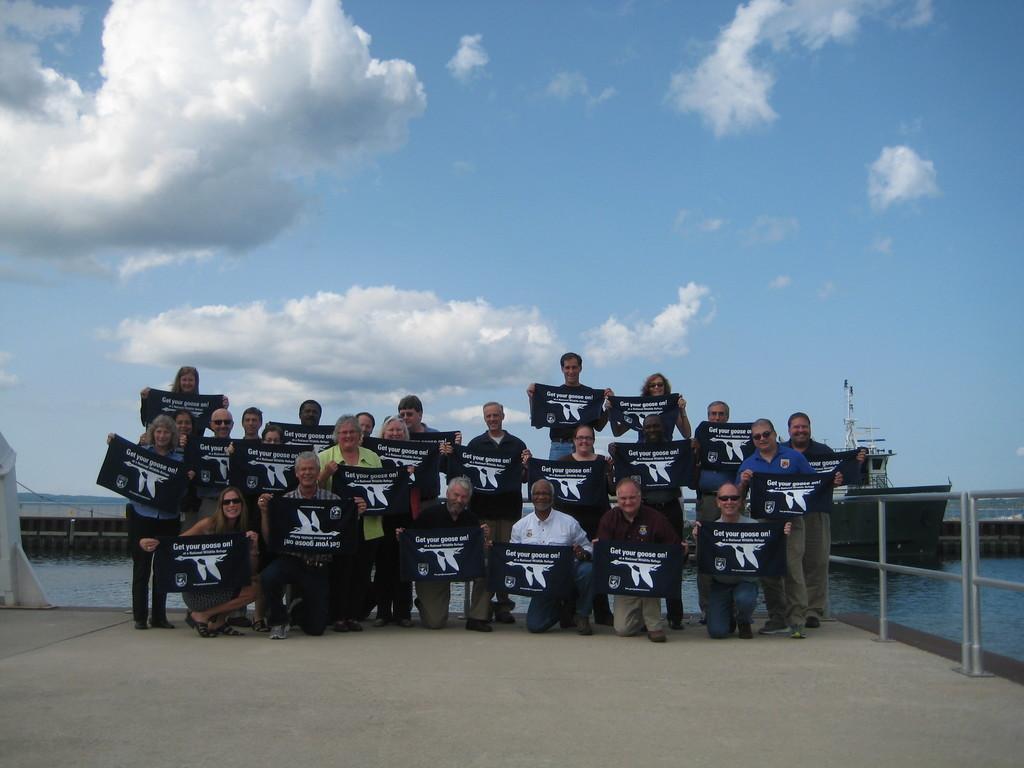How would you summarize this image in a sentence or two? In this image we can see few people holding banners and there is a railing beside the person's, there is a ship on the water, a bridge and the sky with clouds in the background. 